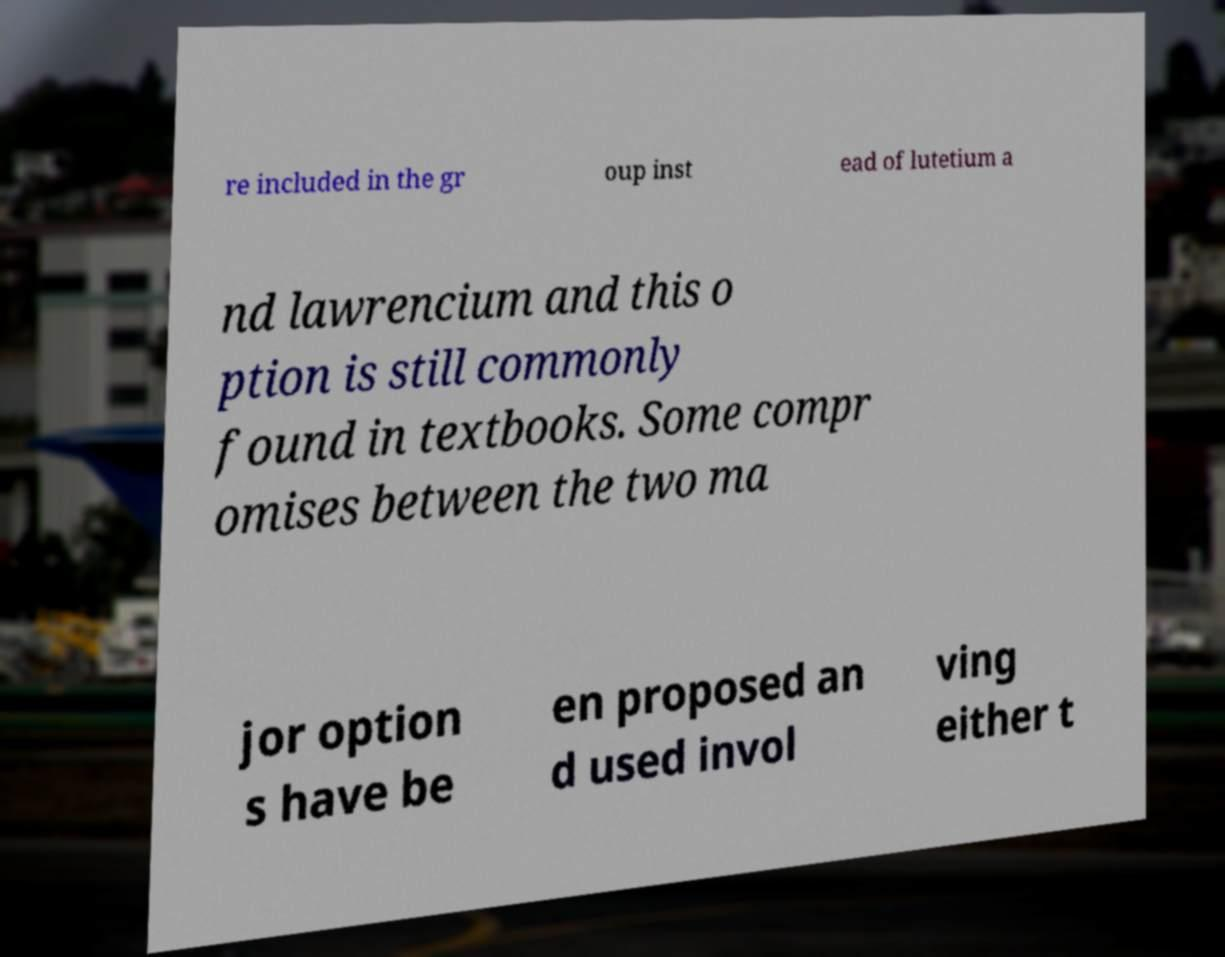Can you accurately transcribe the text from the provided image for me? re included in the gr oup inst ead of lutetium a nd lawrencium and this o ption is still commonly found in textbooks. Some compr omises between the two ma jor option s have be en proposed an d used invol ving either t 